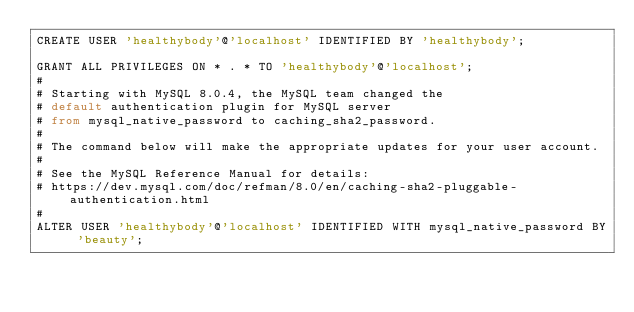<code> <loc_0><loc_0><loc_500><loc_500><_SQL_>CREATE USER 'healthybody'@'localhost' IDENTIFIED BY 'healthybody';

GRANT ALL PRIVILEGES ON * . * TO 'healthybody'@'localhost';
#
# Starting with MySQL 8.0.4, the MySQL team changed the 
# default authentication plugin for MySQL server 
# from mysql_native_password to caching_sha2_password.
#
# The command below will make the appropriate updates for your user account.
#
# See the MySQL Reference Manual for details: 
# https://dev.mysql.com/doc/refman/8.0/en/caching-sha2-pluggable-authentication.html
#
ALTER USER 'healthybody'@'localhost' IDENTIFIED WITH mysql_native_password BY 'beauty';</code> 